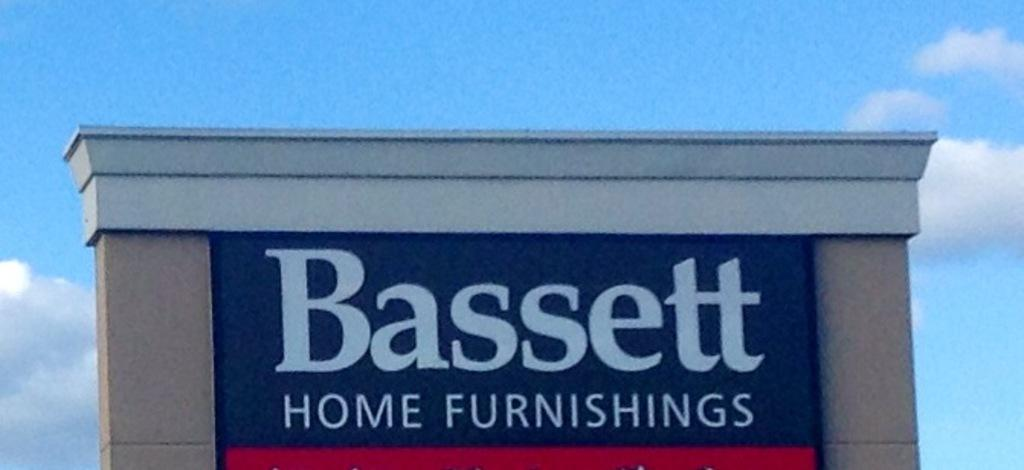What is attached to the wall in the image? There is a board on the wall in the image. What can be seen in the background of the image? The background of the image includes a cloudy sky. What is written or displayed on the board? There is some text visible in the image. What type of yarn is being used to create the plate in the image? There is no plate or yarn present in the image. What type of cloth is draped over the board in the image? There is no cloth draped over the board in the image; only the board and text are present. 